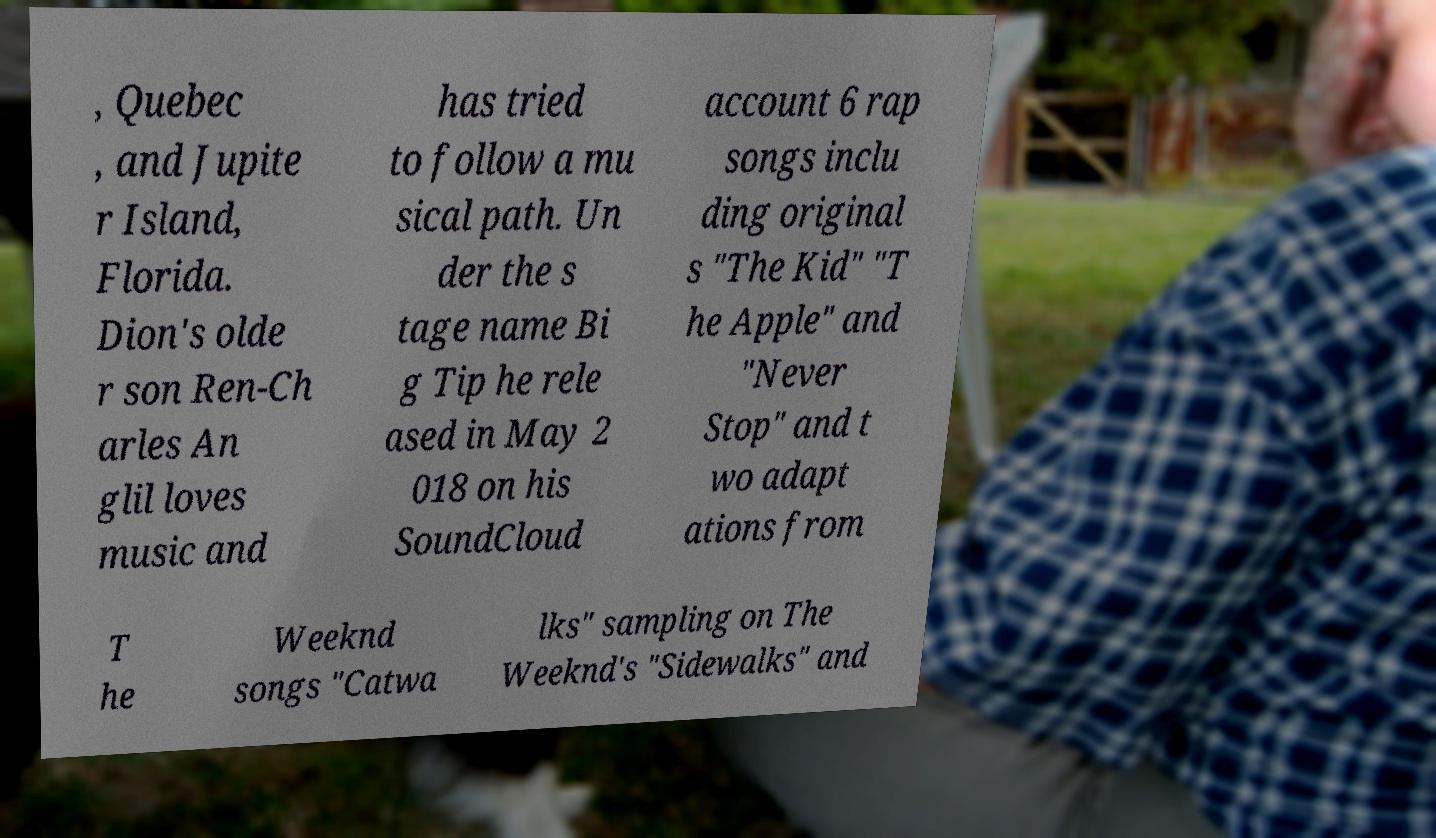Could you extract and type out the text from this image? , Quebec , and Jupite r Island, Florida. Dion's olde r son Ren-Ch arles An glil loves music and has tried to follow a mu sical path. Un der the s tage name Bi g Tip he rele ased in May 2 018 on his SoundCloud account 6 rap songs inclu ding original s "The Kid" "T he Apple" and "Never Stop" and t wo adapt ations from T he Weeknd songs "Catwa lks" sampling on The Weeknd's "Sidewalks" and 